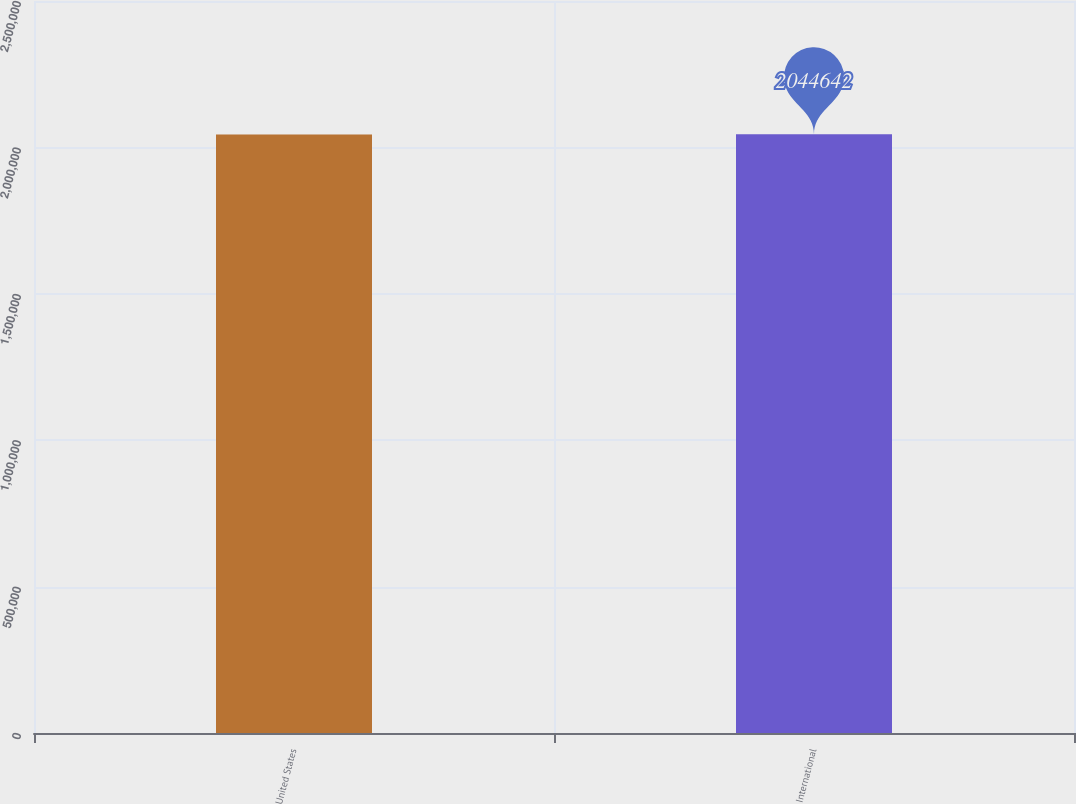<chart> <loc_0><loc_0><loc_500><loc_500><bar_chart><fcel>United States<fcel>International<nl><fcel>2.04434e+06<fcel>2.04464e+06<nl></chart> 